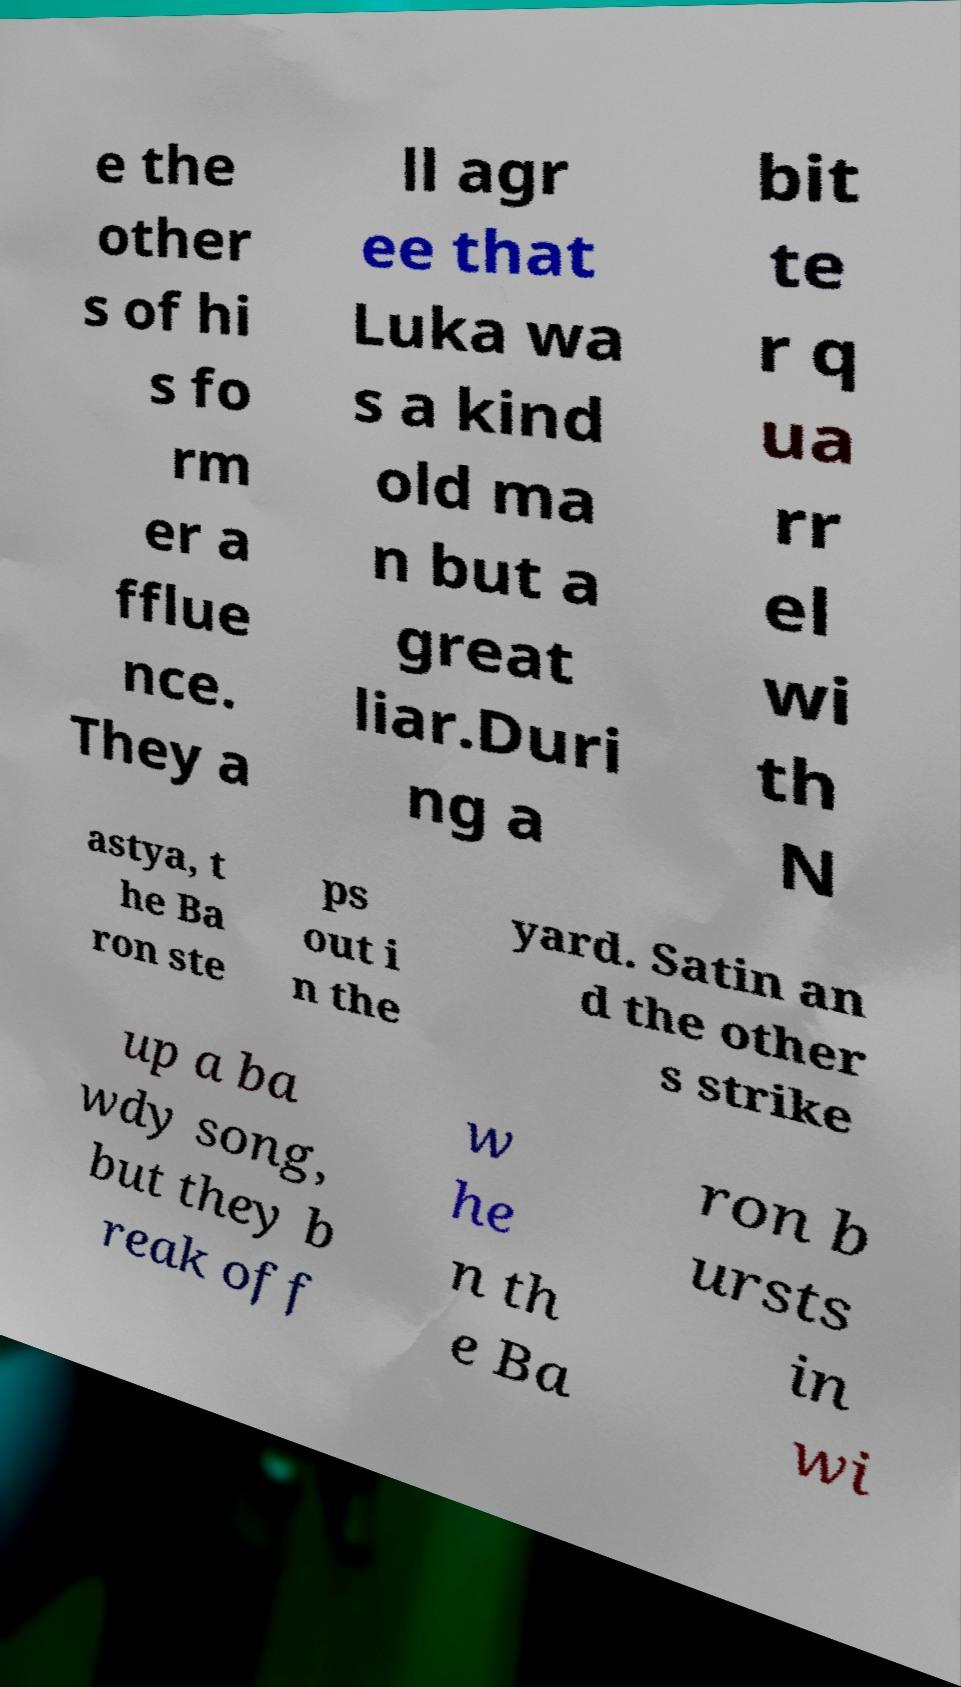I need the written content from this picture converted into text. Can you do that? e the other s of hi s fo rm er a fflue nce. They a ll agr ee that Luka wa s a kind old ma n but a great liar.Duri ng a bit te r q ua rr el wi th N astya, t he Ba ron ste ps out i n the yard. Satin an d the other s strike up a ba wdy song, but they b reak off w he n th e Ba ron b ursts in wi 